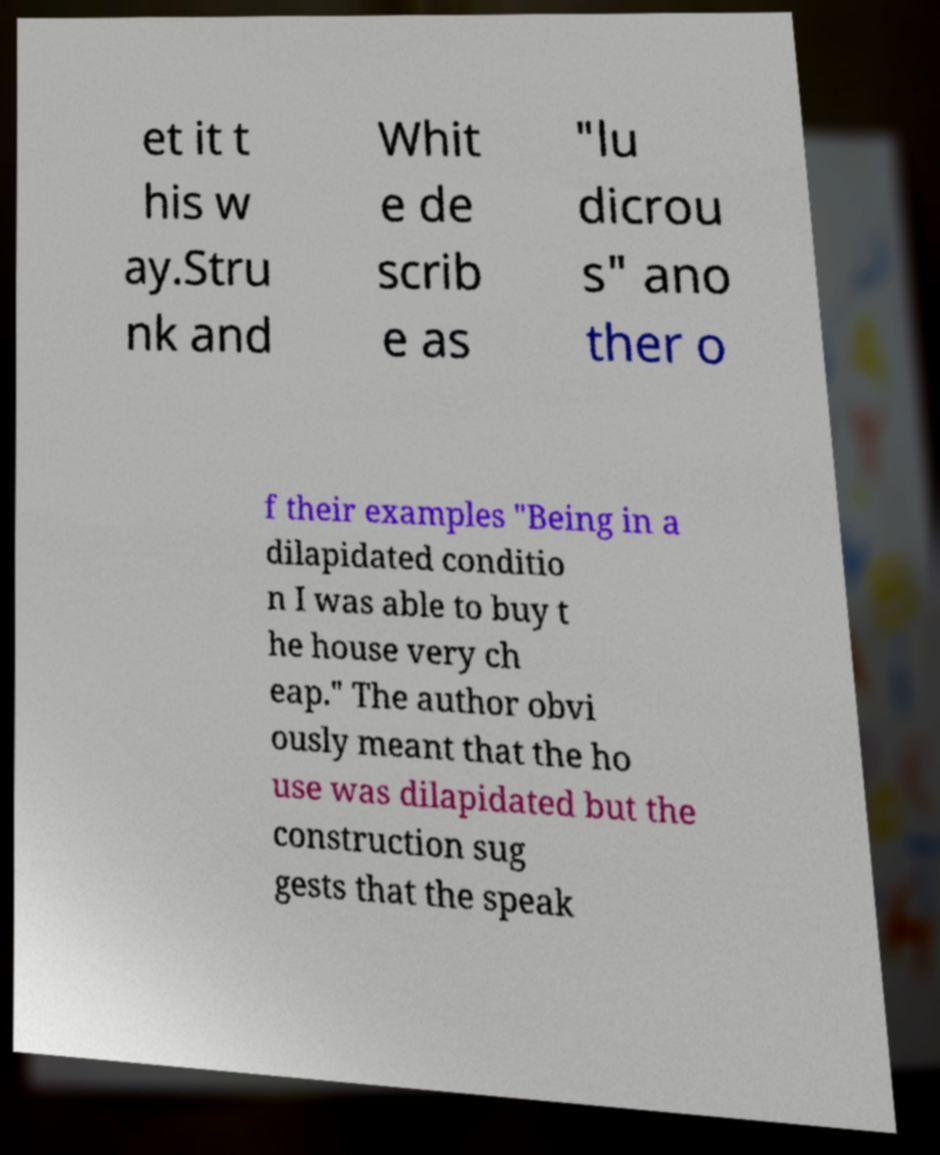Could you assist in decoding the text presented in this image and type it out clearly? et it t his w ay.Stru nk and Whit e de scrib e as "lu dicrou s" ano ther o f their examples "Being in a dilapidated conditio n I was able to buy t he house very ch eap." The author obvi ously meant that the ho use was dilapidated but the construction sug gests that the speak 